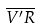Convert formula to latex. <formula><loc_0><loc_0><loc_500><loc_500>\overline { V ^ { \prime } R }</formula> 